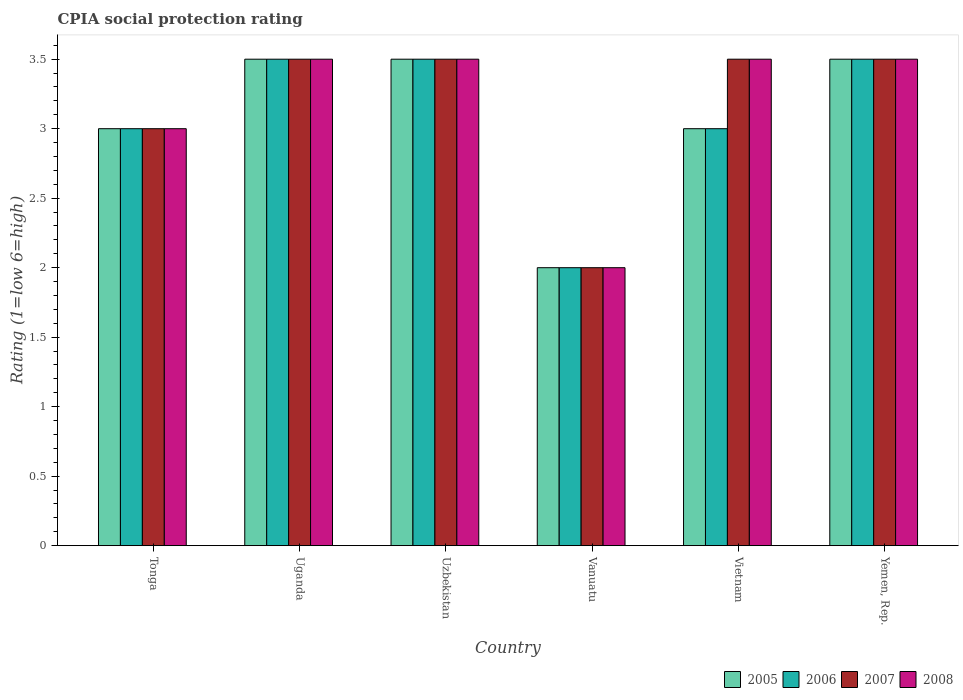How many groups of bars are there?
Provide a succinct answer. 6. Are the number of bars per tick equal to the number of legend labels?
Offer a terse response. Yes. How many bars are there on the 4th tick from the left?
Give a very brief answer. 4. What is the label of the 3rd group of bars from the left?
Ensure brevity in your answer.  Uzbekistan. What is the CPIA rating in 2008 in Uzbekistan?
Offer a terse response. 3.5. Across all countries, what is the minimum CPIA rating in 2008?
Provide a short and direct response. 2. In which country was the CPIA rating in 2006 maximum?
Offer a very short reply. Uganda. In which country was the CPIA rating in 2006 minimum?
Make the answer very short. Vanuatu. What is the difference between the CPIA rating in 2005 in Uganda and that in Uzbekistan?
Offer a very short reply. 0. What is the average CPIA rating in 2006 per country?
Give a very brief answer. 3.08. In how many countries, is the CPIA rating in 2008 greater than 2.6?
Your answer should be compact. 5. What is the difference between the highest and the lowest CPIA rating in 2005?
Make the answer very short. 1.5. In how many countries, is the CPIA rating in 2006 greater than the average CPIA rating in 2006 taken over all countries?
Offer a terse response. 3. Is the sum of the CPIA rating in 2006 in Uganda and Vanuatu greater than the maximum CPIA rating in 2008 across all countries?
Ensure brevity in your answer.  Yes. Is it the case that in every country, the sum of the CPIA rating in 2007 and CPIA rating in 2008 is greater than the CPIA rating in 2006?
Ensure brevity in your answer.  Yes. How many bars are there?
Provide a short and direct response. 24. Are all the bars in the graph horizontal?
Offer a terse response. No. How many countries are there in the graph?
Keep it short and to the point. 6. What is the difference between two consecutive major ticks on the Y-axis?
Provide a short and direct response. 0.5. Does the graph contain any zero values?
Ensure brevity in your answer.  No. How are the legend labels stacked?
Your response must be concise. Horizontal. What is the title of the graph?
Make the answer very short. CPIA social protection rating. What is the label or title of the Y-axis?
Give a very brief answer. Rating (1=low 6=high). What is the Rating (1=low 6=high) of 2007 in Tonga?
Give a very brief answer. 3. What is the Rating (1=low 6=high) in 2005 in Uganda?
Your answer should be very brief. 3.5. What is the Rating (1=low 6=high) in 2008 in Uganda?
Your answer should be very brief. 3.5. What is the Rating (1=low 6=high) of 2005 in Uzbekistan?
Ensure brevity in your answer.  3.5. What is the Rating (1=low 6=high) of 2006 in Uzbekistan?
Make the answer very short. 3.5. What is the Rating (1=low 6=high) of 2007 in Uzbekistan?
Offer a terse response. 3.5. What is the Rating (1=low 6=high) of 2008 in Uzbekistan?
Your answer should be very brief. 3.5. What is the Rating (1=low 6=high) in 2005 in Vanuatu?
Provide a short and direct response. 2. What is the Rating (1=low 6=high) of 2006 in Vanuatu?
Make the answer very short. 2. What is the Rating (1=low 6=high) in 2007 in Vanuatu?
Provide a short and direct response. 2. What is the Rating (1=low 6=high) of 2006 in Vietnam?
Your answer should be compact. 3. What is the Rating (1=low 6=high) of 2007 in Vietnam?
Give a very brief answer. 3.5. What is the Rating (1=low 6=high) of 2008 in Vietnam?
Provide a succinct answer. 3.5. What is the Rating (1=low 6=high) of 2006 in Yemen, Rep.?
Make the answer very short. 3.5. What is the Rating (1=low 6=high) of 2008 in Yemen, Rep.?
Your answer should be very brief. 3.5. Across all countries, what is the maximum Rating (1=low 6=high) of 2007?
Offer a terse response. 3.5. Across all countries, what is the minimum Rating (1=low 6=high) in 2006?
Make the answer very short. 2. What is the total Rating (1=low 6=high) of 2005 in the graph?
Your answer should be very brief. 18.5. What is the total Rating (1=low 6=high) of 2007 in the graph?
Offer a terse response. 19. What is the total Rating (1=low 6=high) in 2008 in the graph?
Keep it short and to the point. 19. What is the difference between the Rating (1=low 6=high) of 2005 in Tonga and that in Uganda?
Your answer should be very brief. -0.5. What is the difference between the Rating (1=low 6=high) of 2006 in Tonga and that in Uganda?
Ensure brevity in your answer.  -0.5. What is the difference between the Rating (1=low 6=high) in 2008 in Tonga and that in Uganda?
Your answer should be compact. -0.5. What is the difference between the Rating (1=low 6=high) of 2005 in Tonga and that in Uzbekistan?
Make the answer very short. -0.5. What is the difference between the Rating (1=low 6=high) of 2007 in Tonga and that in Uzbekistan?
Give a very brief answer. -0.5. What is the difference between the Rating (1=low 6=high) in 2008 in Tonga and that in Uzbekistan?
Provide a succinct answer. -0.5. What is the difference between the Rating (1=low 6=high) of 2005 in Tonga and that in Vanuatu?
Your answer should be very brief. 1. What is the difference between the Rating (1=low 6=high) in 2007 in Tonga and that in Vanuatu?
Your answer should be compact. 1. What is the difference between the Rating (1=low 6=high) in 2008 in Tonga and that in Vanuatu?
Your response must be concise. 1. What is the difference between the Rating (1=low 6=high) in 2007 in Tonga and that in Vietnam?
Keep it short and to the point. -0.5. What is the difference between the Rating (1=low 6=high) in 2008 in Tonga and that in Vietnam?
Provide a short and direct response. -0.5. What is the difference between the Rating (1=low 6=high) in 2005 in Uganda and that in Uzbekistan?
Provide a short and direct response. 0. What is the difference between the Rating (1=low 6=high) in 2006 in Uganda and that in Uzbekistan?
Your answer should be compact. 0. What is the difference between the Rating (1=low 6=high) in 2007 in Uganda and that in Uzbekistan?
Your answer should be very brief. 0. What is the difference between the Rating (1=low 6=high) of 2008 in Uganda and that in Uzbekistan?
Offer a very short reply. 0. What is the difference between the Rating (1=low 6=high) in 2005 in Uganda and that in Vanuatu?
Make the answer very short. 1.5. What is the difference between the Rating (1=low 6=high) in 2006 in Uganda and that in Vanuatu?
Your answer should be very brief. 1.5. What is the difference between the Rating (1=low 6=high) of 2008 in Uganda and that in Vanuatu?
Provide a succinct answer. 1.5. What is the difference between the Rating (1=low 6=high) in 2006 in Uganda and that in Vietnam?
Offer a terse response. 0.5. What is the difference between the Rating (1=low 6=high) of 2007 in Uganda and that in Vietnam?
Provide a succinct answer. 0. What is the difference between the Rating (1=low 6=high) of 2008 in Uganda and that in Vietnam?
Your answer should be very brief. 0. What is the difference between the Rating (1=low 6=high) of 2005 in Uganda and that in Yemen, Rep.?
Your answer should be compact. 0. What is the difference between the Rating (1=low 6=high) in 2006 in Uzbekistan and that in Vanuatu?
Offer a very short reply. 1.5. What is the difference between the Rating (1=low 6=high) of 2007 in Uzbekistan and that in Vanuatu?
Your response must be concise. 1.5. What is the difference between the Rating (1=low 6=high) of 2007 in Uzbekistan and that in Yemen, Rep.?
Make the answer very short. 0. What is the difference between the Rating (1=low 6=high) of 2008 in Uzbekistan and that in Yemen, Rep.?
Make the answer very short. 0. What is the difference between the Rating (1=low 6=high) in 2005 in Vanuatu and that in Vietnam?
Make the answer very short. -1. What is the difference between the Rating (1=low 6=high) in 2008 in Vanuatu and that in Vietnam?
Make the answer very short. -1.5. What is the difference between the Rating (1=low 6=high) in 2005 in Vanuatu and that in Yemen, Rep.?
Provide a succinct answer. -1.5. What is the difference between the Rating (1=low 6=high) of 2007 in Vanuatu and that in Yemen, Rep.?
Ensure brevity in your answer.  -1.5. What is the difference between the Rating (1=low 6=high) in 2005 in Vietnam and that in Yemen, Rep.?
Your answer should be very brief. -0.5. What is the difference between the Rating (1=low 6=high) of 2008 in Vietnam and that in Yemen, Rep.?
Offer a terse response. 0. What is the difference between the Rating (1=low 6=high) in 2005 in Tonga and the Rating (1=low 6=high) in 2006 in Uganda?
Your answer should be compact. -0.5. What is the difference between the Rating (1=low 6=high) in 2005 in Tonga and the Rating (1=low 6=high) in 2008 in Uganda?
Keep it short and to the point. -0.5. What is the difference between the Rating (1=low 6=high) of 2006 in Tonga and the Rating (1=low 6=high) of 2007 in Uganda?
Provide a short and direct response. -0.5. What is the difference between the Rating (1=low 6=high) of 2007 in Tonga and the Rating (1=low 6=high) of 2008 in Uganda?
Provide a succinct answer. -0.5. What is the difference between the Rating (1=low 6=high) of 2005 in Tonga and the Rating (1=low 6=high) of 2006 in Uzbekistan?
Give a very brief answer. -0.5. What is the difference between the Rating (1=low 6=high) in 2006 in Tonga and the Rating (1=low 6=high) in 2007 in Uzbekistan?
Keep it short and to the point. -0.5. What is the difference between the Rating (1=low 6=high) of 2006 in Tonga and the Rating (1=low 6=high) of 2008 in Uzbekistan?
Your answer should be compact. -0.5. What is the difference between the Rating (1=low 6=high) in 2007 in Tonga and the Rating (1=low 6=high) in 2008 in Uzbekistan?
Give a very brief answer. -0.5. What is the difference between the Rating (1=low 6=high) in 2005 in Tonga and the Rating (1=low 6=high) in 2006 in Vanuatu?
Give a very brief answer. 1. What is the difference between the Rating (1=low 6=high) of 2005 in Tonga and the Rating (1=low 6=high) of 2008 in Vanuatu?
Provide a short and direct response. 1. What is the difference between the Rating (1=low 6=high) in 2007 in Tonga and the Rating (1=low 6=high) in 2008 in Vanuatu?
Offer a terse response. 1. What is the difference between the Rating (1=low 6=high) in 2005 in Tonga and the Rating (1=low 6=high) in 2006 in Vietnam?
Provide a succinct answer. 0. What is the difference between the Rating (1=low 6=high) of 2006 in Tonga and the Rating (1=low 6=high) of 2007 in Vietnam?
Offer a very short reply. -0.5. What is the difference between the Rating (1=low 6=high) in 2007 in Tonga and the Rating (1=low 6=high) in 2008 in Vietnam?
Make the answer very short. -0.5. What is the difference between the Rating (1=low 6=high) in 2005 in Tonga and the Rating (1=low 6=high) in 2006 in Yemen, Rep.?
Make the answer very short. -0.5. What is the difference between the Rating (1=low 6=high) in 2005 in Tonga and the Rating (1=low 6=high) in 2007 in Yemen, Rep.?
Offer a terse response. -0.5. What is the difference between the Rating (1=low 6=high) of 2007 in Tonga and the Rating (1=low 6=high) of 2008 in Yemen, Rep.?
Your response must be concise. -0.5. What is the difference between the Rating (1=low 6=high) of 2005 in Uganda and the Rating (1=low 6=high) of 2007 in Uzbekistan?
Provide a short and direct response. 0. What is the difference between the Rating (1=low 6=high) in 2005 in Uganda and the Rating (1=low 6=high) in 2008 in Uzbekistan?
Your response must be concise. 0. What is the difference between the Rating (1=low 6=high) in 2007 in Uganda and the Rating (1=low 6=high) in 2008 in Uzbekistan?
Make the answer very short. 0. What is the difference between the Rating (1=low 6=high) of 2005 in Uganda and the Rating (1=low 6=high) of 2006 in Vanuatu?
Your answer should be very brief. 1.5. What is the difference between the Rating (1=low 6=high) of 2005 in Uganda and the Rating (1=low 6=high) of 2007 in Vanuatu?
Provide a short and direct response. 1.5. What is the difference between the Rating (1=low 6=high) in 2006 in Uganda and the Rating (1=low 6=high) in 2008 in Vanuatu?
Make the answer very short. 1.5. What is the difference between the Rating (1=low 6=high) of 2005 in Uganda and the Rating (1=low 6=high) of 2006 in Vietnam?
Your answer should be compact. 0.5. What is the difference between the Rating (1=low 6=high) of 2005 in Uganda and the Rating (1=low 6=high) of 2007 in Vietnam?
Make the answer very short. 0. What is the difference between the Rating (1=low 6=high) of 2005 in Uganda and the Rating (1=low 6=high) of 2008 in Vietnam?
Give a very brief answer. 0. What is the difference between the Rating (1=low 6=high) in 2006 in Uganda and the Rating (1=low 6=high) in 2007 in Vietnam?
Your response must be concise. 0. What is the difference between the Rating (1=low 6=high) in 2005 in Uganda and the Rating (1=low 6=high) in 2008 in Yemen, Rep.?
Your answer should be compact. 0. What is the difference between the Rating (1=low 6=high) in 2006 in Uganda and the Rating (1=low 6=high) in 2007 in Yemen, Rep.?
Keep it short and to the point. 0. What is the difference between the Rating (1=low 6=high) of 2005 in Uzbekistan and the Rating (1=low 6=high) of 2006 in Vanuatu?
Make the answer very short. 1.5. What is the difference between the Rating (1=low 6=high) in 2005 in Uzbekistan and the Rating (1=low 6=high) in 2007 in Vanuatu?
Offer a terse response. 1.5. What is the difference between the Rating (1=low 6=high) in 2006 in Uzbekistan and the Rating (1=low 6=high) in 2007 in Vanuatu?
Your response must be concise. 1.5. What is the difference between the Rating (1=low 6=high) of 2005 in Uzbekistan and the Rating (1=low 6=high) of 2007 in Vietnam?
Ensure brevity in your answer.  0. What is the difference between the Rating (1=low 6=high) of 2005 in Uzbekistan and the Rating (1=low 6=high) of 2008 in Vietnam?
Your answer should be compact. 0. What is the difference between the Rating (1=low 6=high) of 2006 in Uzbekistan and the Rating (1=low 6=high) of 2008 in Vietnam?
Offer a very short reply. 0. What is the difference between the Rating (1=low 6=high) in 2007 in Uzbekistan and the Rating (1=low 6=high) in 2008 in Vietnam?
Offer a terse response. 0. What is the difference between the Rating (1=low 6=high) in 2005 in Uzbekistan and the Rating (1=low 6=high) in 2007 in Yemen, Rep.?
Your answer should be compact. 0. What is the difference between the Rating (1=low 6=high) of 2007 in Uzbekistan and the Rating (1=low 6=high) of 2008 in Yemen, Rep.?
Give a very brief answer. 0. What is the difference between the Rating (1=low 6=high) of 2006 in Vanuatu and the Rating (1=low 6=high) of 2007 in Vietnam?
Your answer should be very brief. -1.5. What is the difference between the Rating (1=low 6=high) in 2007 in Vanuatu and the Rating (1=low 6=high) in 2008 in Vietnam?
Keep it short and to the point. -1.5. What is the difference between the Rating (1=low 6=high) in 2005 in Vanuatu and the Rating (1=low 6=high) in 2006 in Yemen, Rep.?
Provide a short and direct response. -1.5. What is the difference between the Rating (1=low 6=high) in 2006 in Vanuatu and the Rating (1=low 6=high) in 2007 in Yemen, Rep.?
Give a very brief answer. -1.5. What is the difference between the Rating (1=low 6=high) of 2007 in Vietnam and the Rating (1=low 6=high) of 2008 in Yemen, Rep.?
Give a very brief answer. 0. What is the average Rating (1=low 6=high) of 2005 per country?
Make the answer very short. 3.08. What is the average Rating (1=low 6=high) in 2006 per country?
Your answer should be very brief. 3.08. What is the average Rating (1=low 6=high) in 2007 per country?
Offer a terse response. 3.17. What is the average Rating (1=low 6=high) in 2008 per country?
Offer a very short reply. 3.17. What is the difference between the Rating (1=low 6=high) of 2005 and Rating (1=low 6=high) of 2006 in Tonga?
Give a very brief answer. 0. What is the difference between the Rating (1=low 6=high) of 2005 and Rating (1=low 6=high) of 2007 in Tonga?
Your answer should be very brief. 0. What is the difference between the Rating (1=low 6=high) in 2005 and Rating (1=low 6=high) in 2008 in Tonga?
Provide a succinct answer. 0. What is the difference between the Rating (1=low 6=high) of 2006 and Rating (1=low 6=high) of 2007 in Tonga?
Offer a terse response. 0. What is the difference between the Rating (1=low 6=high) in 2006 and Rating (1=low 6=high) in 2008 in Tonga?
Give a very brief answer. 0. What is the difference between the Rating (1=low 6=high) in 2005 and Rating (1=low 6=high) in 2006 in Uganda?
Offer a very short reply. 0. What is the difference between the Rating (1=low 6=high) in 2006 and Rating (1=low 6=high) in 2007 in Uganda?
Offer a terse response. 0. What is the difference between the Rating (1=low 6=high) of 2005 and Rating (1=low 6=high) of 2008 in Uzbekistan?
Provide a succinct answer. 0. What is the difference between the Rating (1=low 6=high) in 2006 and Rating (1=low 6=high) in 2007 in Uzbekistan?
Provide a succinct answer. 0. What is the difference between the Rating (1=low 6=high) in 2005 and Rating (1=low 6=high) in 2006 in Vanuatu?
Provide a short and direct response. 0. What is the difference between the Rating (1=low 6=high) in 2005 and Rating (1=low 6=high) in 2008 in Vanuatu?
Ensure brevity in your answer.  0. What is the difference between the Rating (1=low 6=high) of 2007 and Rating (1=low 6=high) of 2008 in Vanuatu?
Keep it short and to the point. 0. What is the difference between the Rating (1=low 6=high) of 2005 and Rating (1=low 6=high) of 2006 in Vietnam?
Keep it short and to the point. 0. What is the difference between the Rating (1=low 6=high) of 2005 and Rating (1=low 6=high) of 2008 in Vietnam?
Make the answer very short. -0.5. What is the difference between the Rating (1=low 6=high) of 2006 and Rating (1=low 6=high) of 2007 in Vietnam?
Give a very brief answer. -0.5. What is the difference between the Rating (1=low 6=high) of 2005 and Rating (1=low 6=high) of 2006 in Yemen, Rep.?
Your answer should be compact. 0. What is the difference between the Rating (1=low 6=high) in 2005 and Rating (1=low 6=high) in 2008 in Yemen, Rep.?
Your answer should be very brief. 0. What is the ratio of the Rating (1=low 6=high) in 2005 in Tonga to that in Uganda?
Give a very brief answer. 0.86. What is the ratio of the Rating (1=low 6=high) in 2008 in Tonga to that in Uganda?
Offer a very short reply. 0.86. What is the ratio of the Rating (1=low 6=high) of 2006 in Tonga to that in Uzbekistan?
Your answer should be compact. 0.86. What is the ratio of the Rating (1=low 6=high) of 2007 in Tonga to that in Uzbekistan?
Provide a short and direct response. 0.86. What is the ratio of the Rating (1=low 6=high) of 2008 in Tonga to that in Uzbekistan?
Give a very brief answer. 0.86. What is the ratio of the Rating (1=low 6=high) of 2005 in Tonga to that in Vanuatu?
Keep it short and to the point. 1.5. What is the ratio of the Rating (1=low 6=high) of 2006 in Tonga to that in Vanuatu?
Provide a succinct answer. 1.5. What is the ratio of the Rating (1=low 6=high) of 2005 in Tonga to that in Vietnam?
Offer a terse response. 1. What is the ratio of the Rating (1=low 6=high) of 2006 in Tonga to that in Vietnam?
Make the answer very short. 1. What is the ratio of the Rating (1=low 6=high) of 2006 in Tonga to that in Yemen, Rep.?
Provide a succinct answer. 0.86. What is the ratio of the Rating (1=low 6=high) in 2007 in Tonga to that in Yemen, Rep.?
Ensure brevity in your answer.  0.86. What is the ratio of the Rating (1=low 6=high) in 2007 in Uganda to that in Uzbekistan?
Make the answer very short. 1. What is the ratio of the Rating (1=low 6=high) in 2008 in Uganda to that in Uzbekistan?
Make the answer very short. 1. What is the ratio of the Rating (1=low 6=high) in 2005 in Uganda to that in Vanuatu?
Offer a very short reply. 1.75. What is the ratio of the Rating (1=low 6=high) of 2007 in Uganda to that in Vanuatu?
Your response must be concise. 1.75. What is the ratio of the Rating (1=low 6=high) in 2008 in Uganda to that in Vietnam?
Offer a terse response. 1. What is the ratio of the Rating (1=low 6=high) of 2007 in Uganda to that in Yemen, Rep.?
Offer a terse response. 1. What is the ratio of the Rating (1=low 6=high) in 2008 in Uzbekistan to that in Vanuatu?
Provide a succinct answer. 1.75. What is the ratio of the Rating (1=low 6=high) in 2005 in Uzbekistan to that in Vietnam?
Make the answer very short. 1.17. What is the ratio of the Rating (1=low 6=high) in 2007 in Uzbekistan to that in Vietnam?
Provide a short and direct response. 1. What is the ratio of the Rating (1=low 6=high) of 2005 in Uzbekistan to that in Yemen, Rep.?
Your response must be concise. 1. What is the ratio of the Rating (1=low 6=high) in 2005 in Vanuatu to that in Vietnam?
Your response must be concise. 0.67. What is the ratio of the Rating (1=low 6=high) in 2007 in Vanuatu to that in Vietnam?
Offer a terse response. 0.57. What is the ratio of the Rating (1=low 6=high) of 2005 in Vanuatu to that in Yemen, Rep.?
Provide a succinct answer. 0.57. What is the ratio of the Rating (1=low 6=high) in 2006 in Vanuatu to that in Yemen, Rep.?
Make the answer very short. 0.57. What is the ratio of the Rating (1=low 6=high) of 2007 in Vanuatu to that in Yemen, Rep.?
Keep it short and to the point. 0.57. What is the ratio of the Rating (1=low 6=high) of 2005 in Vietnam to that in Yemen, Rep.?
Ensure brevity in your answer.  0.86. What is the ratio of the Rating (1=low 6=high) in 2007 in Vietnam to that in Yemen, Rep.?
Your answer should be compact. 1. What is the difference between the highest and the second highest Rating (1=low 6=high) in 2005?
Keep it short and to the point. 0. What is the difference between the highest and the second highest Rating (1=low 6=high) in 2006?
Provide a short and direct response. 0. What is the difference between the highest and the second highest Rating (1=low 6=high) in 2008?
Your response must be concise. 0. What is the difference between the highest and the lowest Rating (1=low 6=high) in 2005?
Make the answer very short. 1.5. What is the difference between the highest and the lowest Rating (1=low 6=high) in 2008?
Provide a short and direct response. 1.5. 